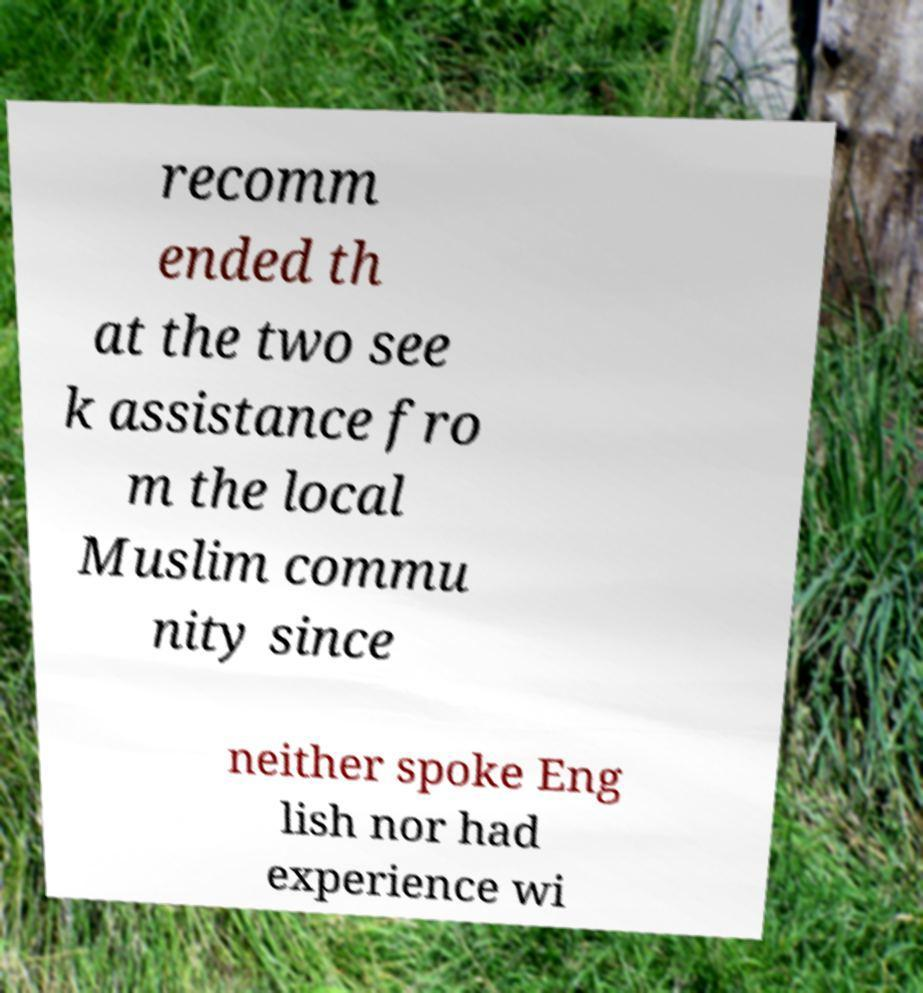There's text embedded in this image that I need extracted. Can you transcribe it verbatim? recomm ended th at the two see k assistance fro m the local Muslim commu nity since neither spoke Eng lish nor had experience wi 